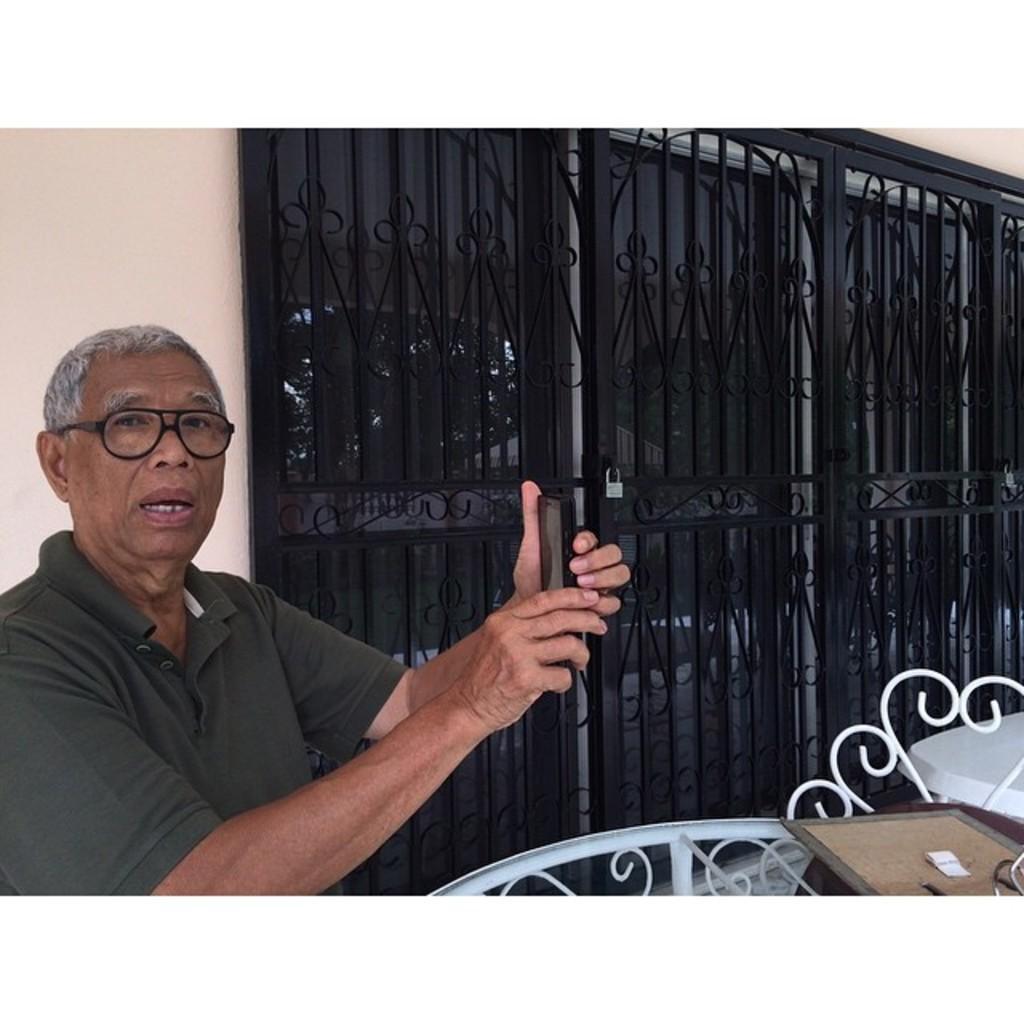Please provide a concise description of this image. In this picture I can see a man holding a mobile in his hand and he wore spectacles and I can see a table and a metal grill to the glass door and I can see a lock. 